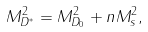Convert formula to latex. <formula><loc_0><loc_0><loc_500><loc_500>M _ { D ^ { * } } ^ { 2 } = M _ { D _ { 0 } } ^ { 2 } + n M _ { s } ^ { 2 } ,</formula> 